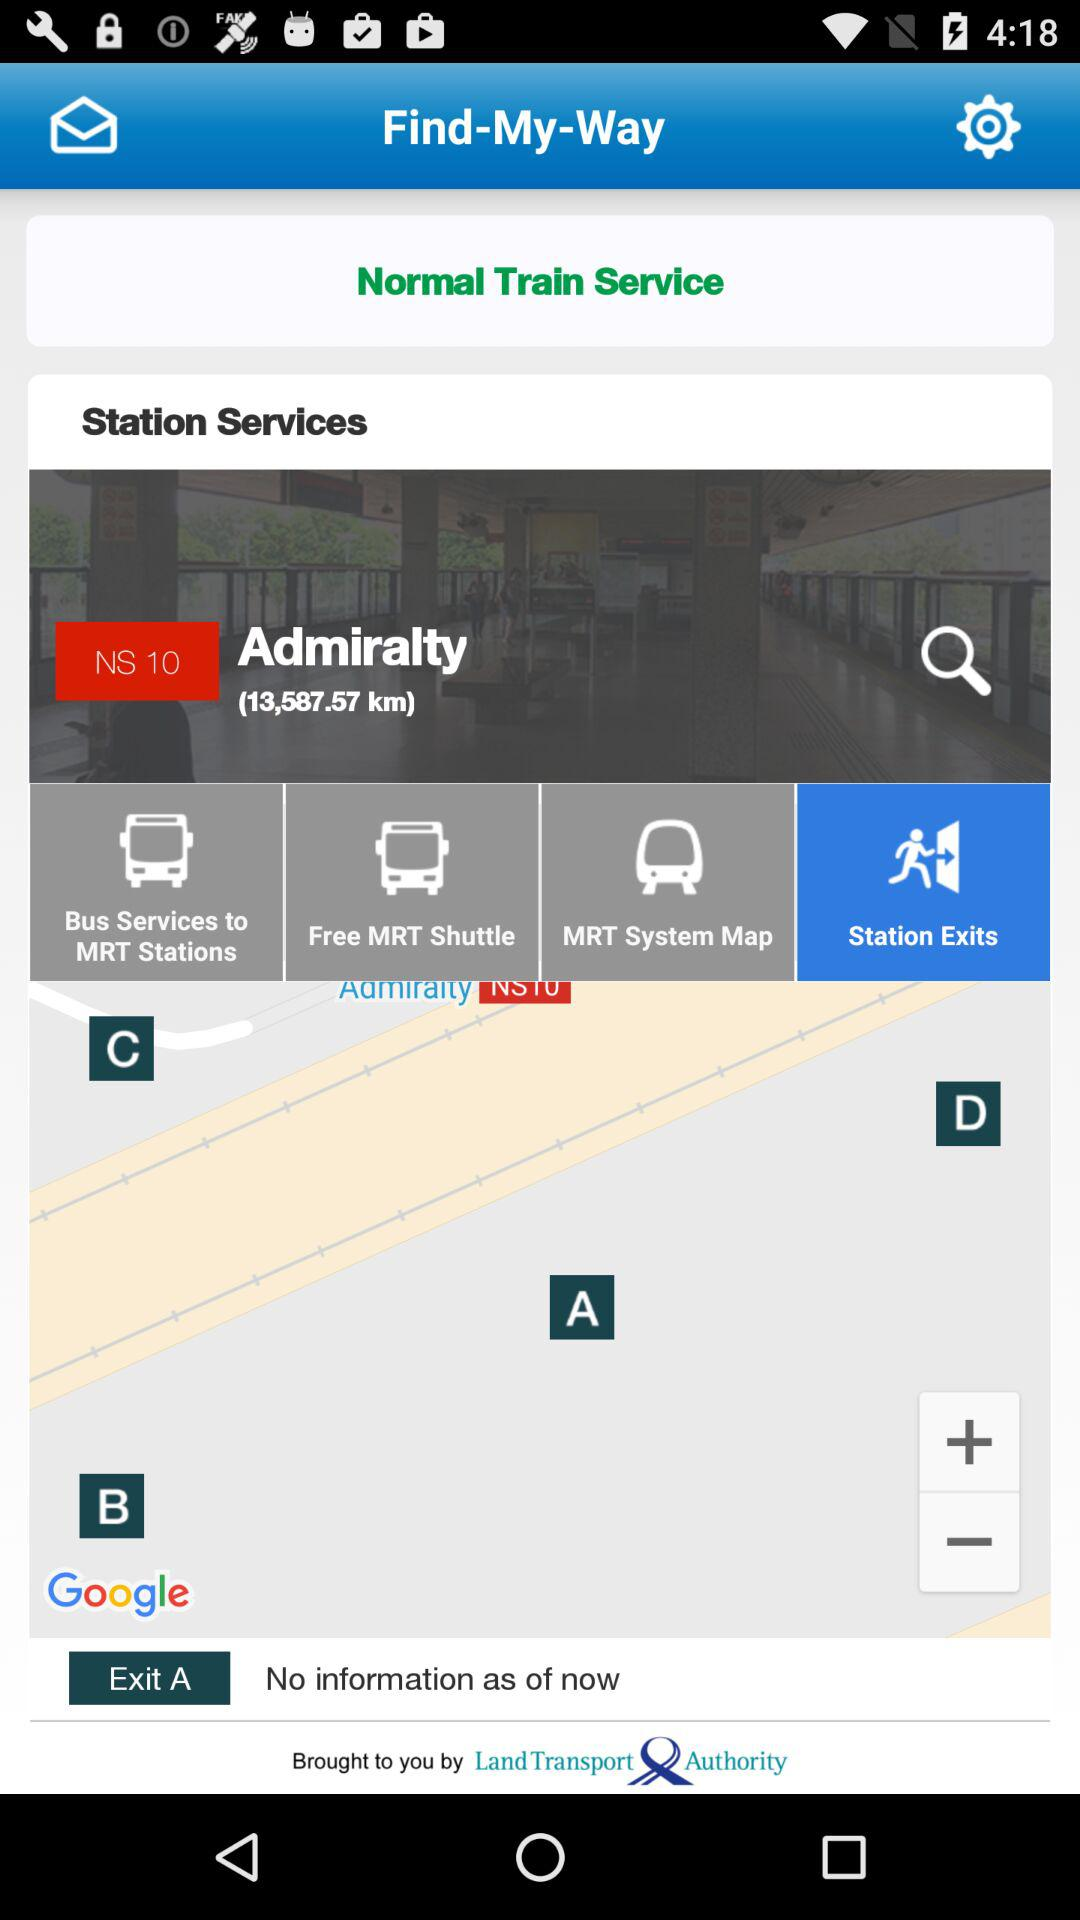How much is the distance to the station? The distance is 13,587.57 km. 